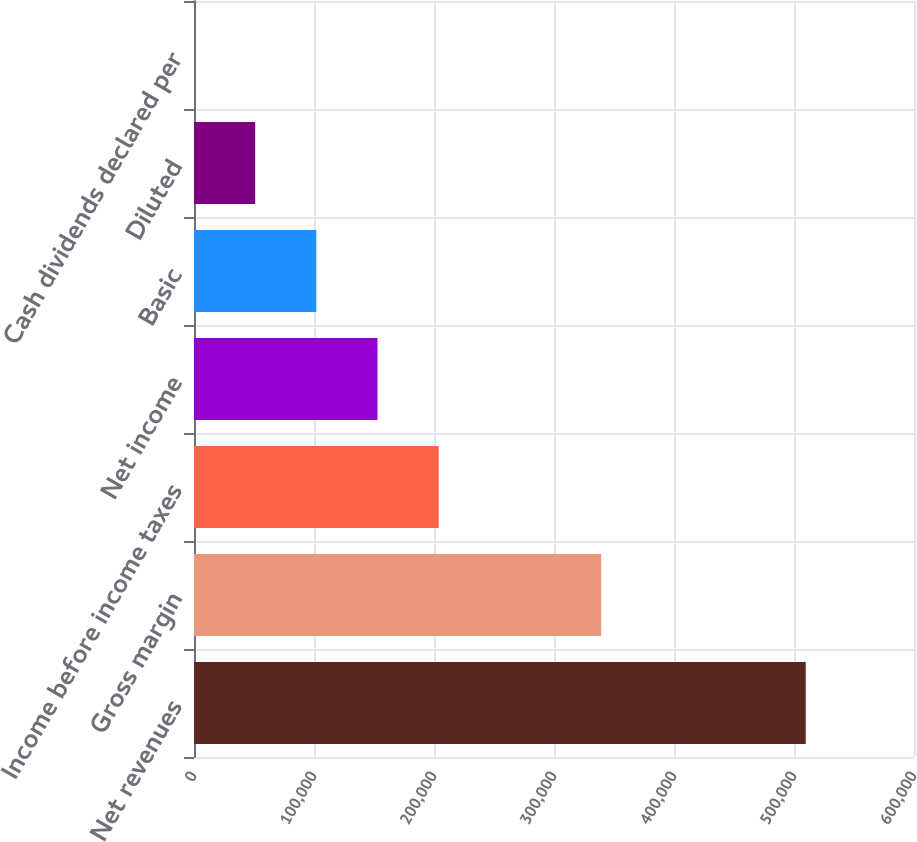<chart> <loc_0><loc_0><loc_500><loc_500><bar_chart><fcel>Net revenues<fcel>Gross margin<fcel>Income before income taxes<fcel>Net income<fcel>Basic<fcel>Diluted<fcel>Cash dividends declared per<nl><fcel>509767<fcel>339274<fcel>203907<fcel>152930<fcel>101954<fcel>50976.9<fcel>0.22<nl></chart> 